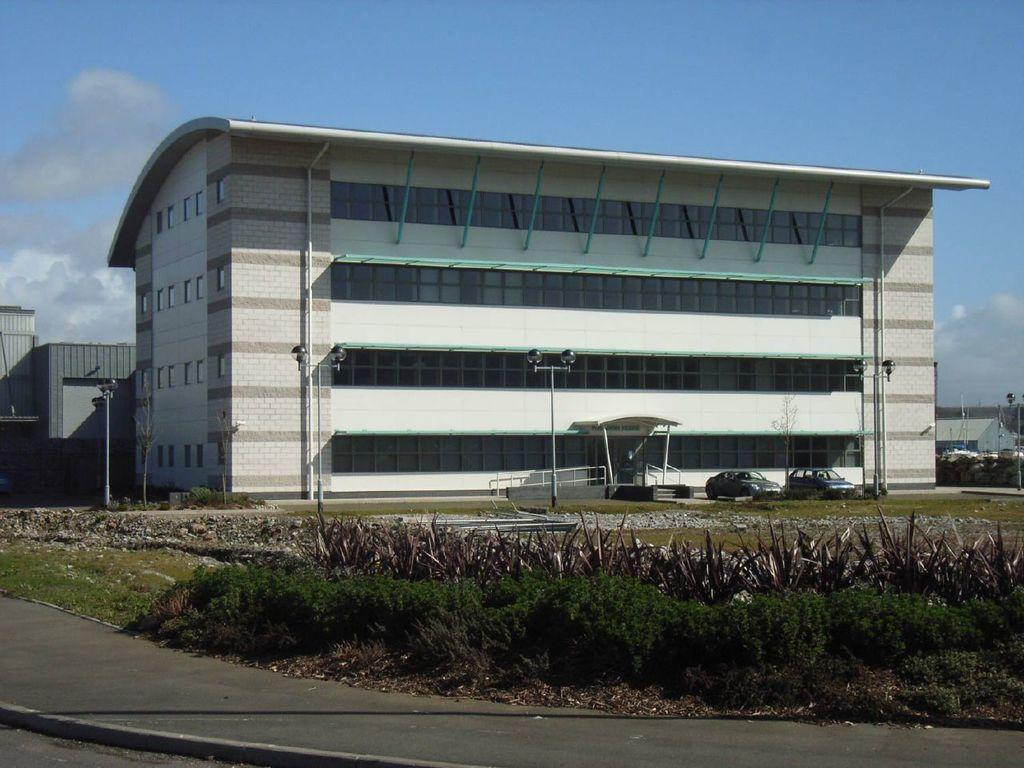What is in the foreground of the image? There is a road and plants in the foreground of the image. What can be seen in the background of the image? There are poles, vehicles, buildings, and the sky visible in the background of the image. Can you describe the sky in the image? The sky is visible in the background of the image, and there is a cloud present. What type of bed can be seen in the image? There is no bed present in the image. How many degrees can be seen in the image? There are no degrees visible in the image; it features a road, plants, poles, vehicles, buildings, and a cloudy sky. 